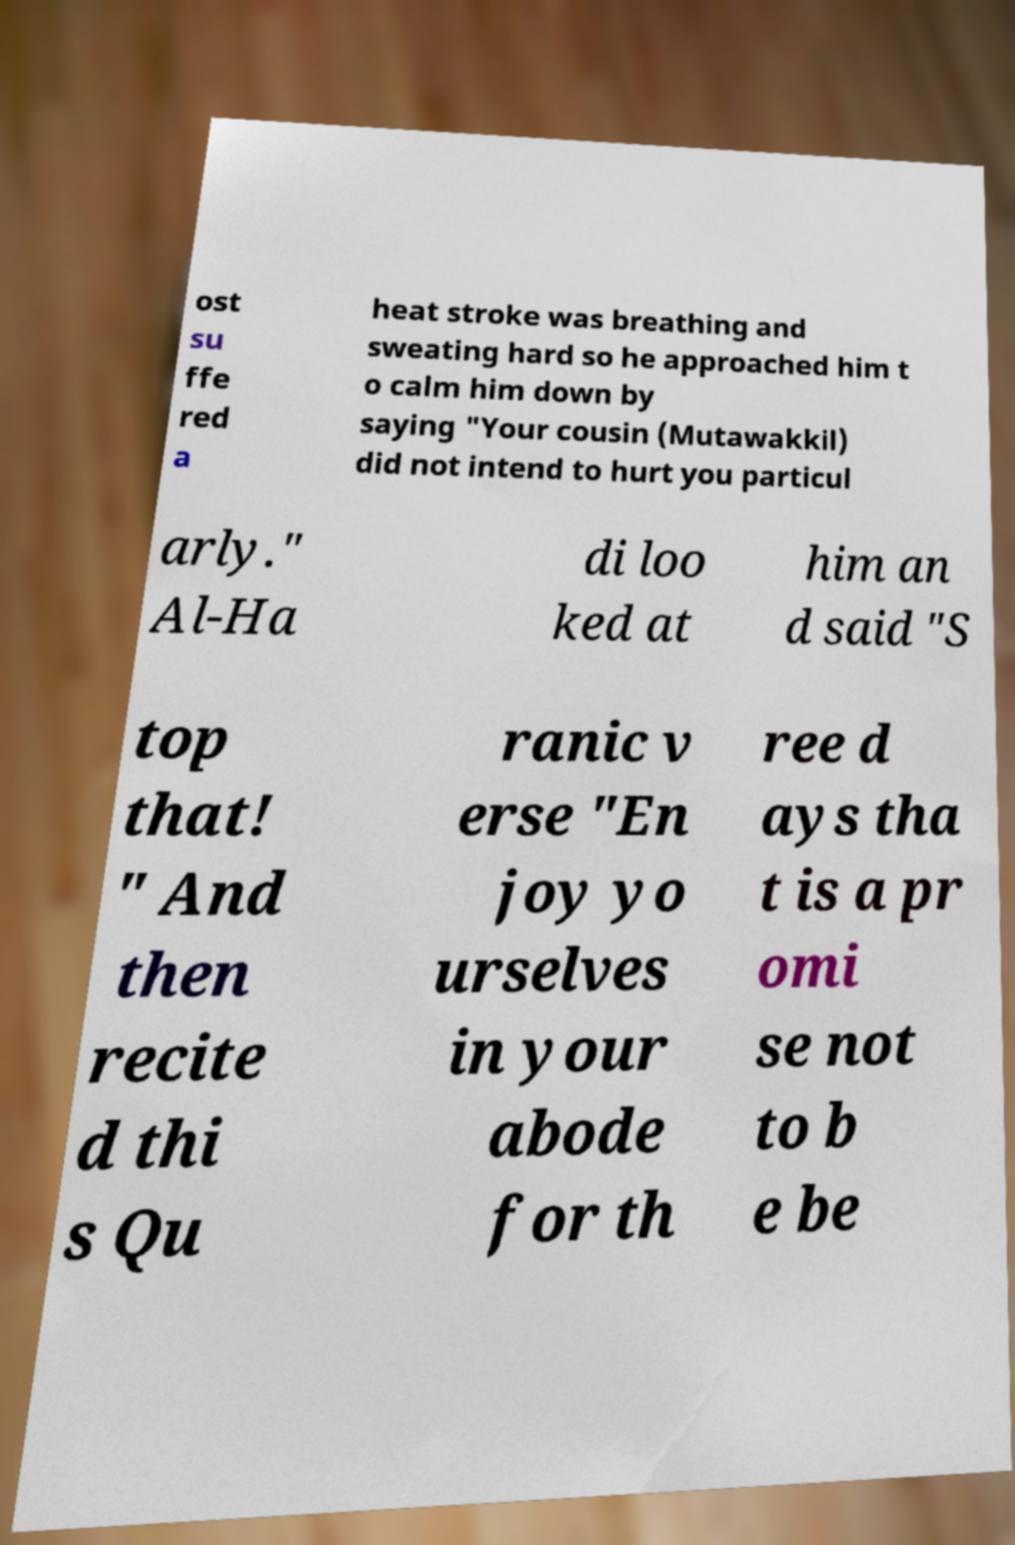I need the written content from this picture converted into text. Can you do that? ost su ffe red a heat stroke was breathing and sweating hard so he approached him t o calm him down by saying "Your cousin (Mutawakkil) did not intend to hurt you particul arly." Al-Ha di loo ked at him an d said "S top that! " And then recite d thi s Qu ranic v erse "En joy yo urselves in your abode for th ree d ays tha t is a pr omi se not to b e be 